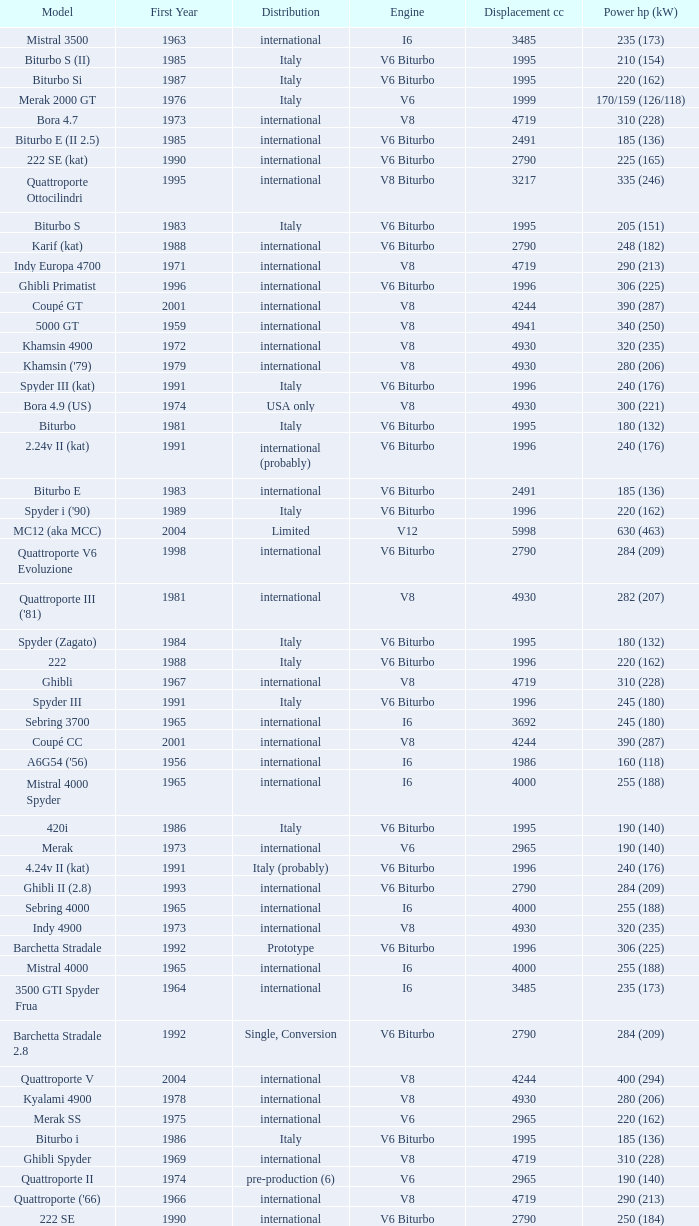What is Power HP (kW), when First Year is greater than 1965, when Distribution is "International", when Engine is V6 Biturbo, and when Model is "425"? 200 (147). 